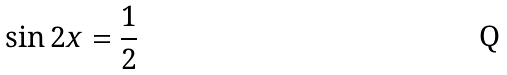<formula> <loc_0><loc_0><loc_500><loc_500>\sin 2 x = \frac { 1 } { 2 }</formula> 